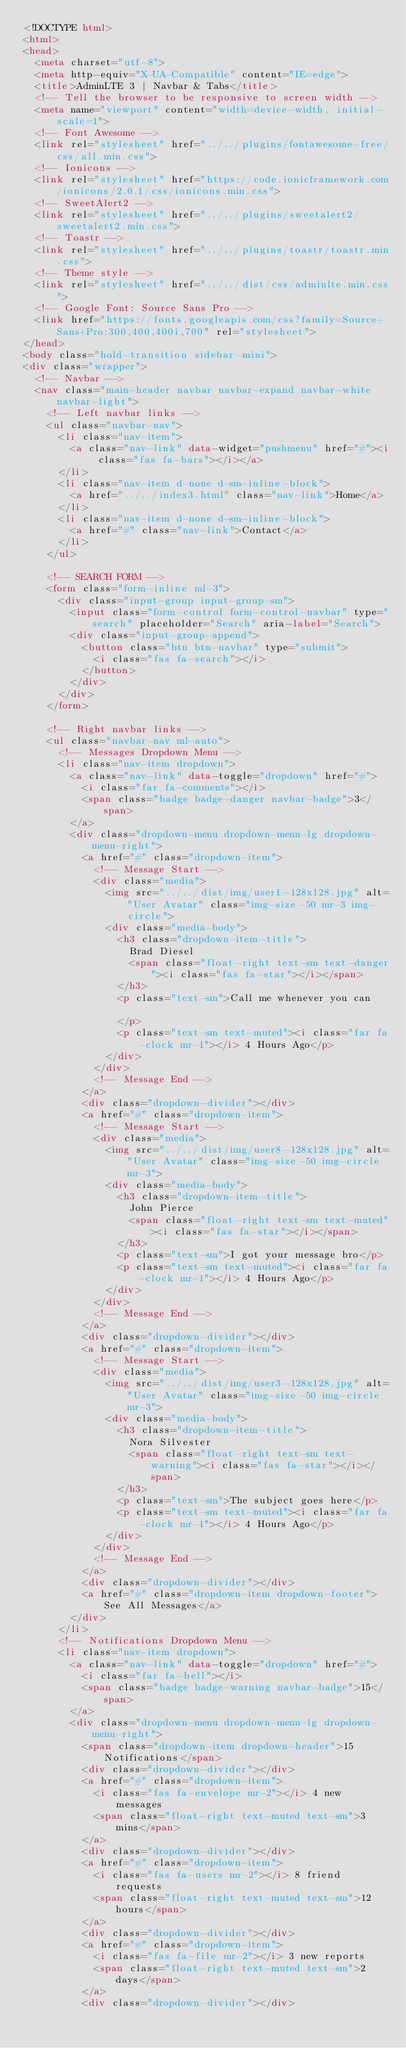Convert code to text. <code><loc_0><loc_0><loc_500><loc_500><_HTML_><!DOCTYPE html>
<html>
<head>
  <meta charset="utf-8">
  <meta http-equiv="X-UA-Compatible" content="IE=edge">
  <title>AdminLTE 3 | Navbar & Tabs</title>
  <!-- Tell the browser to be responsive to screen width -->
  <meta name="viewport" content="width=device-width, initial-scale=1">
  <!-- Font Awesome -->
  <link rel="stylesheet" href="../../plugins/fontawesome-free/css/all.min.css">
  <!-- Ionicons -->
  <link rel="stylesheet" href="https://code.ionicframework.com/ionicons/2.0.1/css/ionicons.min.css">
  <!-- SweetAlert2 -->
  <link rel="stylesheet" href="../../plugins/sweetalert2/sweetalert2.min.css">
  <!-- Toastr -->
  <link rel="stylesheet" href="../../plugins/toastr/toastr.min.css">
  <!-- Theme style -->
  <link rel="stylesheet" href="../../dist/css/adminlte.min.css">
  <!-- Google Font: Source Sans Pro -->
  <link href="https://fonts.googleapis.com/css?family=Source+Sans+Pro:300,400,400i,700" rel="stylesheet">
</head>
<body class="hold-transition sidebar-mini">
<div class="wrapper">
  <!-- Navbar -->
  <nav class="main-header navbar navbar-expand navbar-white navbar-light">
    <!-- Left navbar links -->
    <ul class="navbar-nav">
      <li class="nav-item">
        <a class="nav-link" data-widget="pushmenu" href="#"><i class="fas fa-bars"></i></a>
      </li>
      <li class="nav-item d-none d-sm-inline-block">
        <a href="../../index3.html" class="nav-link">Home</a>
      </li>
      <li class="nav-item d-none d-sm-inline-block">
        <a href="#" class="nav-link">Contact</a>
      </li>
    </ul>

    <!-- SEARCH FORM -->
    <form class="form-inline ml-3">
      <div class="input-group input-group-sm">
        <input class="form-control form-control-navbar" type="search" placeholder="Search" aria-label="Search">
        <div class="input-group-append">
          <button class="btn btn-navbar" type="submit">
            <i class="fas fa-search"></i>
          </button>
        </div>
      </div>
    </form>

    <!-- Right navbar links -->
    <ul class="navbar-nav ml-auto">
      <!-- Messages Dropdown Menu -->
      <li class="nav-item dropdown">
        <a class="nav-link" data-toggle="dropdown" href="#">
          <i class="far fa-comments"></i>
          <span class="badge badge-danger navbar-badge">3</span>
        </a>
        <div class="dropdown-menu dropdown-menu-lg dropdown-menu-right">
          <a href="#" class="dropdown-item">
            <!-- Message Start -->
            <div class="media">
              <img src="../../dist/img/user1-128x128.jpg" alt="User Avatar" class="img-size-50 mr-3 img-circle">
              <div class="media-body">
                <h3 class="dropdown-item-title">
                  Brad Diesel
                  <span class="float-right text-sm text-danger"><i class="fas fa-star"></i></span>
                </h3>
                <p class="text-sm">Call me whenever you can

                </p>
                <p class="text-sm text-muted"><i class="far fa-clock mr-1"></i> 4 Hours Ago</p>
              </div>
            </div>
            <!-- Message End -->
          </a>
          <div class="dropdown-divider"></div>
          <a href="#" class="dropdown-item">
            <!-- Message Start -->
            <div class="media">
              <img src="../../dist/img/user8-128x128.jpg" alt="User Avatar" class="img-size-50 img-circle mr-3">
              <div class="media-body">
                <h3 class="dropdown-item-title">
                  John Pierce
                  <span class="float-right text-sm text-muted"><i class="fas fa-star"></i></span>
                </h3>
                <p class="text-sm">I got your message bro</p>
                <p class="text-sm text-muted"><i class="far fa-clock mr-1"></i> 4 Hours Ago</p>
              </div>
            </div>
            <!-- Message End -->
          </a>
          <div class="dropdown-divider"></div>
          <a href="#" class="dropdown-item">
            <!-- Message Start -->
            <div class="media">
              <img src="../../dist/img/user3-128x128.jpg" alt="User Avatar" class="img-size-50 img-circle mr-3">
              <div class="media-body">
                <h3 class="dropdown-item-title">
                  Nora Silvester
                  <span class="float-right text-sm text-warning"><i class="fas fa-star"></i></span>
                </h3>
                <p class="text-sm">The subject goes here</p>
                <p class="text-sm text-muted"><i class="far fa-clock mr-1"></i> 4 Hours Ago</p>
              </div>
            </div>
            <!-- Message End -->
          </a>
          <div class="dropdown-divider"></div>
          <a href="#" class="dropdown-item dropdown-footer">See All Messages</a>
        </div>
      </li>
      <!-- Notifications Dropdown Menu -->
      <li class="nav-item dropdown">
        <a class="nav-link" data-toggle="dropdown" href="#">
          <i class="far fa-bell"></i>
          <span class="badge badge-warning navbar-badge">15</span>
        </a>
        <div class="dropdown-menu dropdown-menu-lg dropdown-menu-right">
          <span class="dropdown-item dropdown-header">15 Notifications</span>
          <div class="dropdown-divider"></div>
          <a href="#" class="dropdown-item">
            <i class="fas fa-envelope mr-2"></i> 4 new messages
            <span class="float-right text-muted text-sm">3 mins</span>
          </a>
          <div class="dropdown-divider"></div>
          <a href="#" class="dropdown-item">
            <i class="fas fa-users mr-2"></i> 8 friend requests
            <span class="float-right text-muted text-sm">12 hours</span>
          </a>
          <div class="dropdown-divider"></div>
          <a href="#" class="dropdown-item">
            <i class="fas fa-file mr-2"></i> 3 new reports
            <span class="float-right text-muted text-sm">2 days</span>
          </a>
          <div class="dropdown-divider"></div></code> 